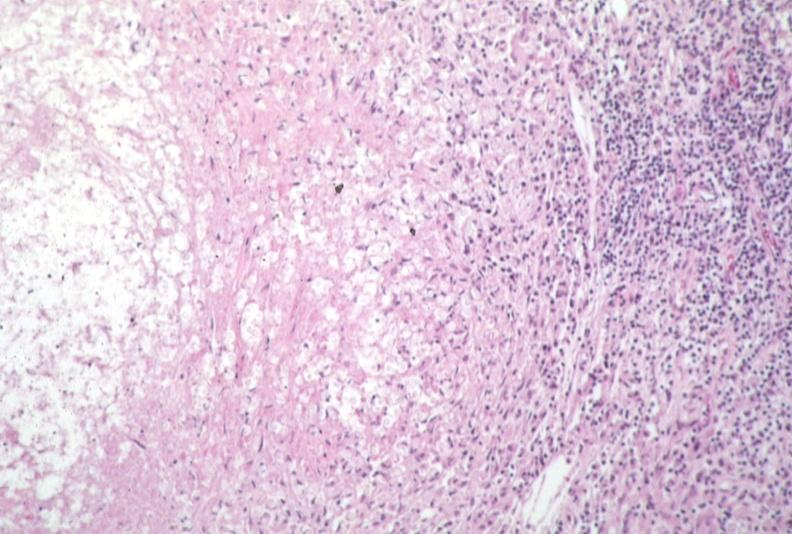does this image show lymph node, cryptococcosis?
Answer the question using a single word or phrase. Yes 